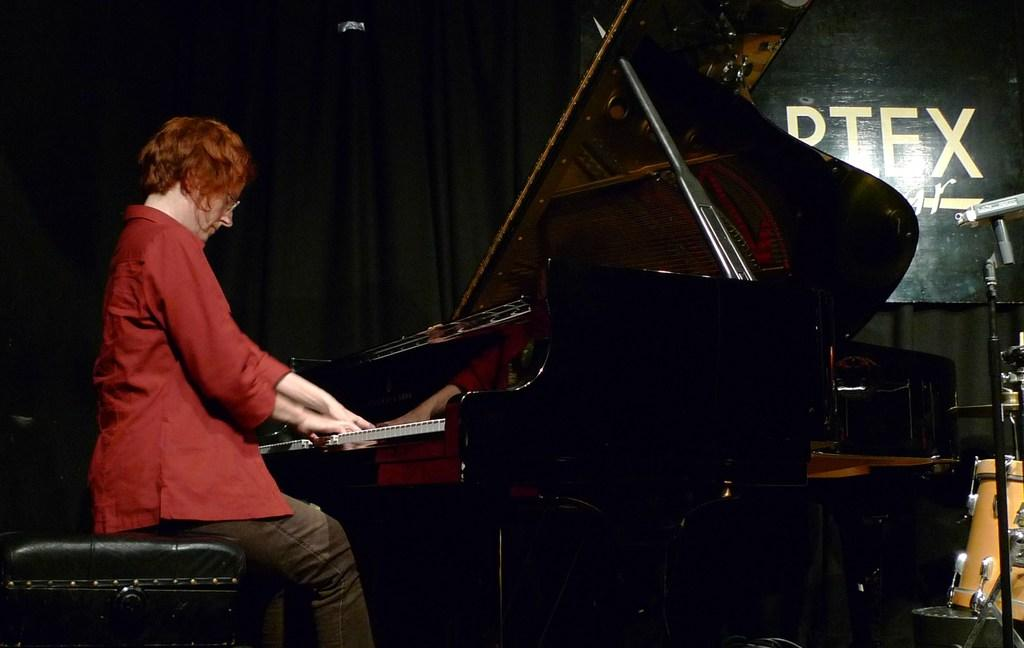Who is the main subject in the image? There is a woman in the image. Where is the woman located in the image? The woman is sitting on the left side. What is the woman doing in the image? The woman is playing a piano. What other musical instrument can be seen in the image? There is a drum in the right corner of the image. What hopeful statement does the woman make while playing the piano in the image? There is no indication in the image that the woman is making any statements, hopeful or otherwise, while playing the piano. 